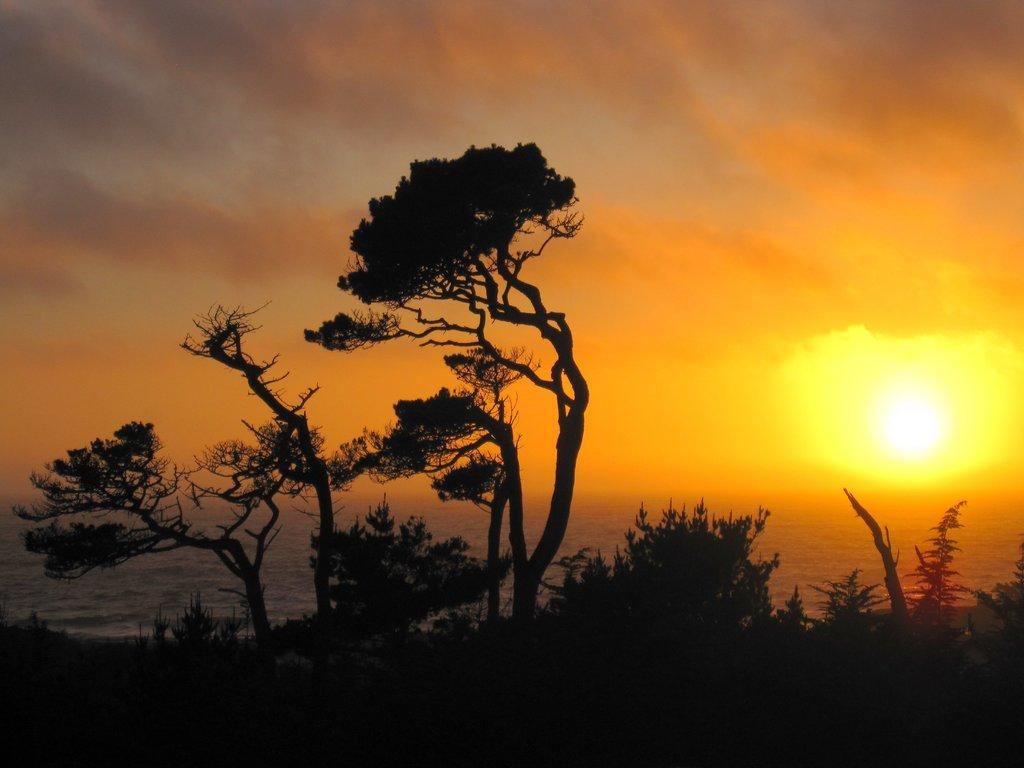What type of vegetation can be seen in the image? There are trees in the image. What natural element is visible in the image? There is water visible in the image. What time of day is suggested by the image? The sunset is observable in the image, suggesting that it is late afternoon or early evening. What type of chicken is present in the image? There is no chicken present in the image. What type of flesh can be seen in the image? There is no flesh visible in the image. 